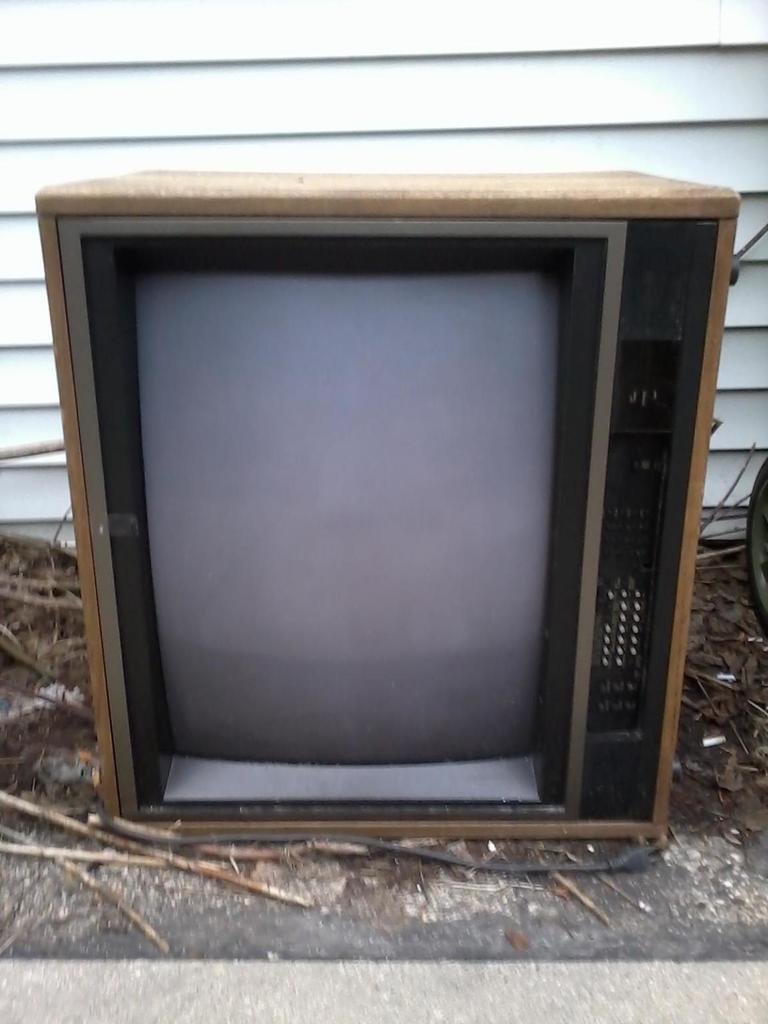What electronic device is visible in the image? There is a television in the image. What objects can be seen on the ground in the image? There are sticks on the ground in the image. Can you describe the white object in the background of the image? Unfortunately, the provided facts do not give enough information to describe the white object in the background. What type of jelly is being used to hold the sticks together in the image? There is no jelly present in the image, and the sticks on the ground are not being held together by any substance. 